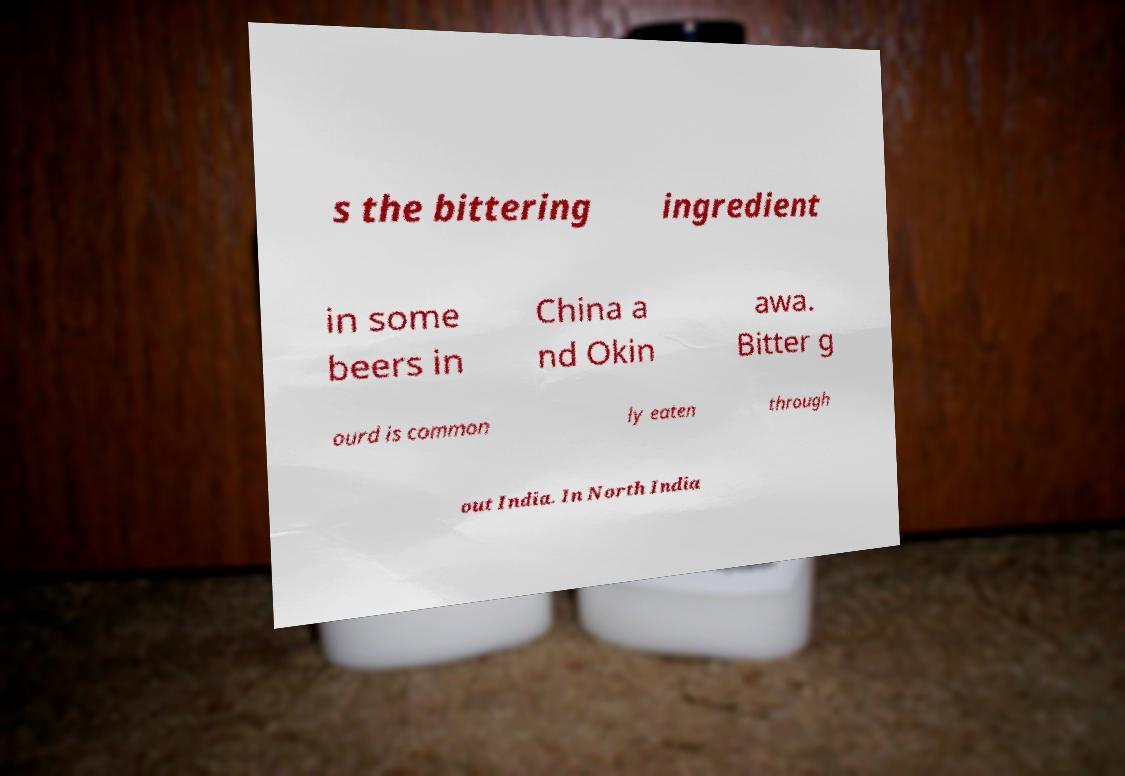Could you assist in decoding the text presented in this image and type it out clearly? s the bittering ingredient in some beers in China a nd Okin awa. Bitter g ourd is common ly eaten through out India. In North India 